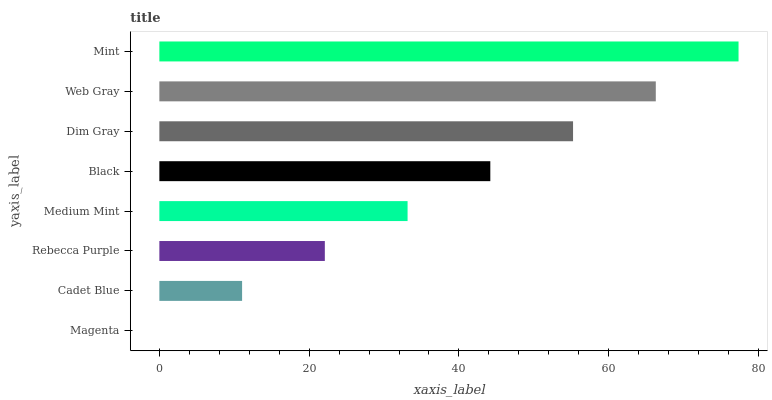Is Magenta the minimum?
Answer yes or no. Yes. Is Mint the maximum?
Answer yes or no. Yes. Is Cadet Blue the minimum?
Answer yes or no. No. Is Cadet Blue the maximum?
Answer yes or no. No. Is Cadet Blue greater than Magenta?
Answer yes or no. Yes. Is Magenta less than Cadet Blue?
Answer yes or no. Yes. Is Magenta greater than Cadet Blue?
Answer yes or no. No. Is Cadet Blue less than Magenta?
Answer yes or no. No. Is Black the high median?
Answer yes or no. Yes. Is Medium Mint the low median?
Answer yes or no. Yes. Is Web Gray the high median?
Answer yes or no. No. Is Rebecca Purple the low median?
Answer yes or no. No. 